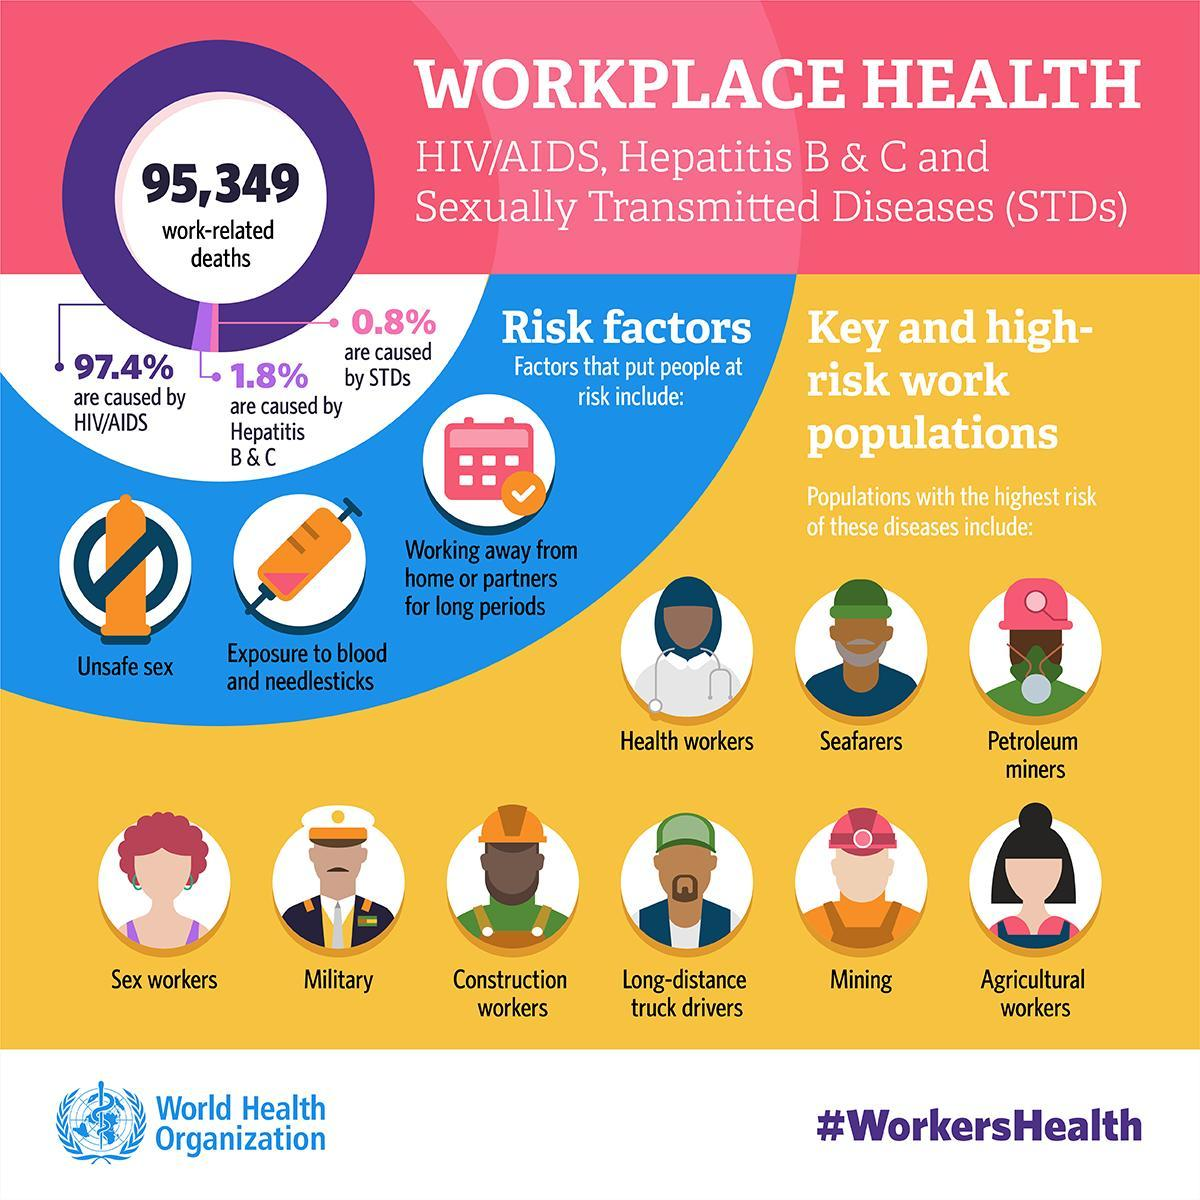Which disease has caused the highest percent of work-related deaths?
Answer the question with a short phrase. HIV/AIDS What percent of the work-related deaths are caused by STDs? 0.8% Which disease has caused 1.8% of the work-related deaths? Hepatitis B & C What percent of the work-related deaths are caused by HIV/AIDS? 97.4% Which disease has caused the least percent of work-related deaths? STDs 